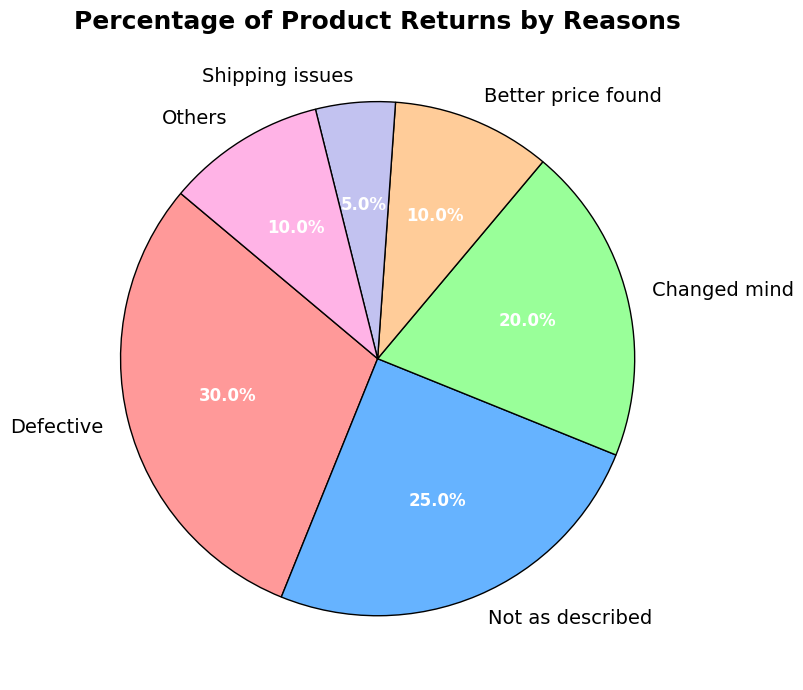What is the most common reason for product returns? The largest segment in the pie chart corresponds to the "Defective" category, which accounts for 30% of product returns.
Answer: Defective What is the combined percentage of returns due to "Not as described" and "Changed mind"? Sum the percentages for "Not as described" (25%) and "Changed mind" (20%), which results in 25 + 20 = 45%.
Answer: 45% Which reason accounts for fewer product returns, "Shipping issues" or "Better price found"? The pie chart shows that "Shipping issues" account for 5% of returns, while "Better price found" accounts for 10%, so "Shipping issues" is fewer.
Answer: Shipping issues What percentage of returns are for reasons other than "Defective"? Subtract the percentage of "Defective" returns (30%) from 100%, which gives 100 - 30 = 70%.
Answer: 70% Which segments of the pie chart have the same size? The pie chart shows that "Better price found" and "Others" both account for 10% of the returns, so they are the same size.
Answer: Better price found and Others What is the second most common reason for product returns? The second largest segment in the pie chart is labeled "Not as described," which accounts for 25% of product returns.
Answer: Not as described How do the percentages of "Changed mind" and "Better price found" compare? "Changed mind" accounts for 20% of returns, while "Better price found" accounts for 10%. Thus, "Changed mind" is double that of "Better price found."
Answer: Changed mind > Better price found What is the combined percentage of the three least common reasons for returns? Add the percentages for "Better price found" (10%), "Shipping issues" (5%), and "Others" (10%), giving 10 + 5 + 10 = 25%.
Answer: 25% Which reason for product return has a purple color in the pie chart? By visually identifying the segment colored purple in the pie chart, it corresponds to "Shipping issues."
Answer: Shipping issues What is the difference in the percentage of returns between the most common and the least common reasons? The most common reason ("Defective") is 30%, and the least common ("Shipping issues") is 5%. The difference is 30 - 5 = 25%.
Answer: 25% 